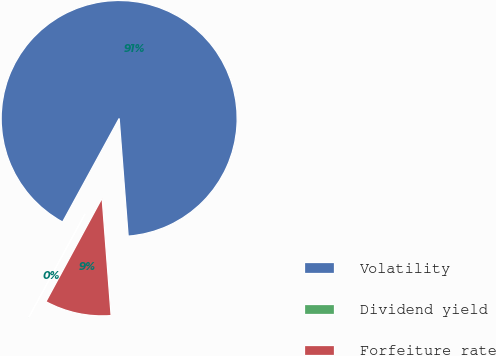Convert chart. <chart><loc_0><loc_0><loc_500><loc_500><pie_chart><fcel>Volatility<fcel>Dividend yield<fcel>Forfeiture rate<nl><fcel>90.83%<fcel>0.05%<fcel>9.12%<nl></chart> 